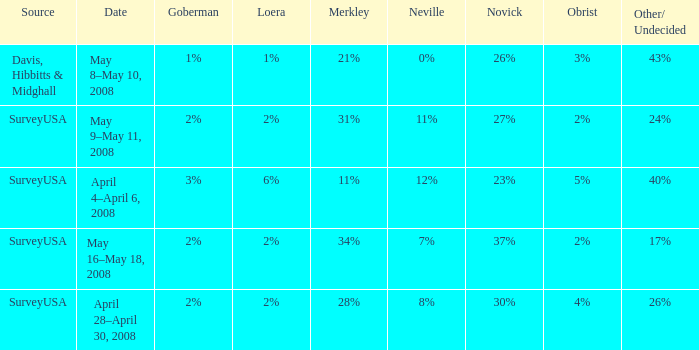Which Neville has a Novick of 23%? 12%. 